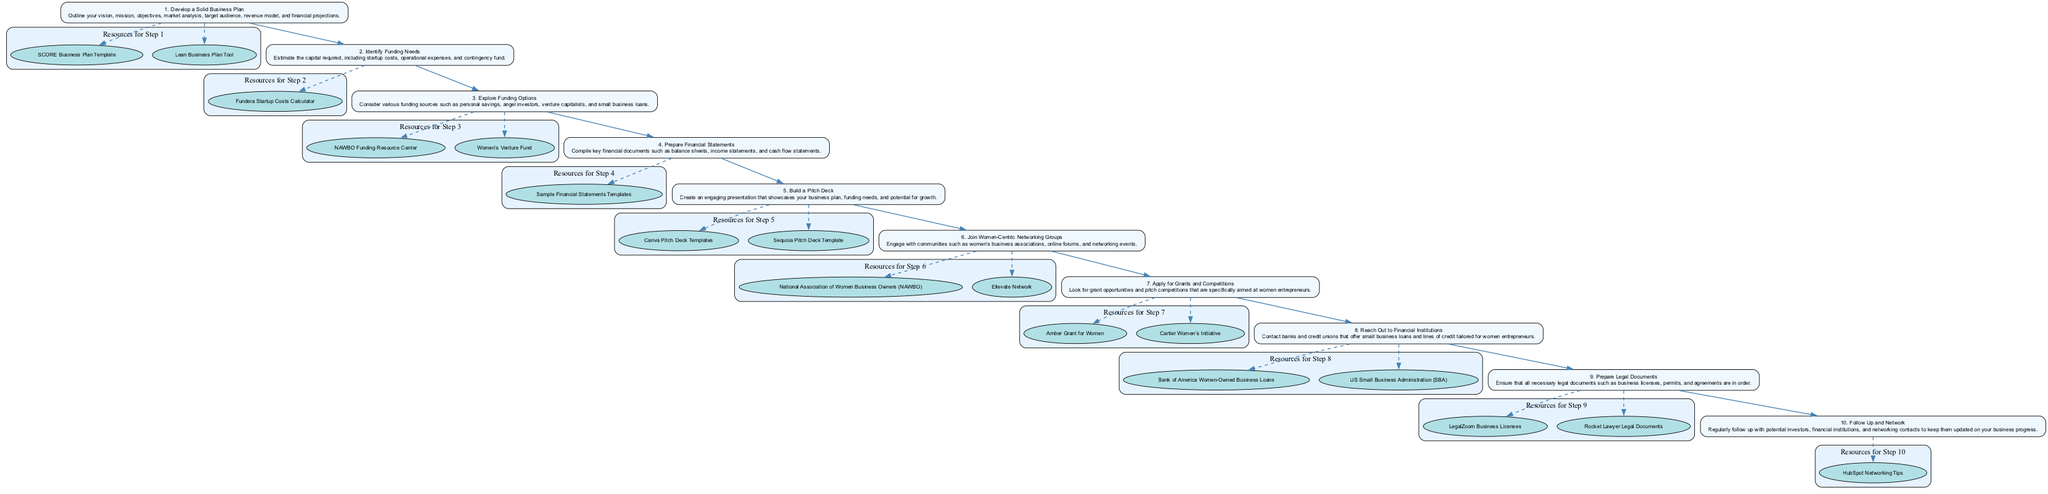What is the first step in securing funding for women-owned startups? The diagram lists "Develop a Solid Business Plan" as the first step, clearly labeled as step 1.
Answer: Develop a Solid Business Plan How many resources are listed for step 5? By reviewing the diagram, it shows that there are 2 resources available for step 5: "Canva Pitch Deck Templates" and "Sequoia Pitch Deck Template".
Answer: 2 What is the last step in the diagram? According to the flow chart, the last step is "Follow Up and Network", which is step 10.
Answer: Follow Up and Network Which step involves preparing financial statements? Looking through the diagram, step 4 is dedicated to preparing financial statements, which is clearly described in the node for that step.
Answer: Prepare Financial Statements Name a resource for identifying funding needs. The diagram indicates that "Fundera Startup Costs Calculator" is a resource associated with step 2, which focuses on identifying funding needs.
Answer: Fundera Startup Costs Calculator Which steps have resources with links? The analysis of the diagram reveals that all steps include resources, each with specific links for further details. Therefore, every step from 1 to 10 has linked resources.
Answer: All steps have resources with links How does step 3 relate to step 5? Reviewing the relationship in the diagram, step 3 involves exploring funding options, which is a crucial element to include in the pitch deck created in step 5, as potential investors are the audience for the pitch.
Answer: Step 3 informs Step 5 What is one of the networking groups mentioned in step 6? In the diagram, the “National Association of Women Business Owners (NAWBO)” is identified as one of the networking groups in step 6.
Answer: National Association of Women Business Owners (NAWBO) How many total steps are there in the diagram? Counting the nodes, there are 10 clear steps in the flow chart, each leading sequentially from the first to the last.
Answer: 10 